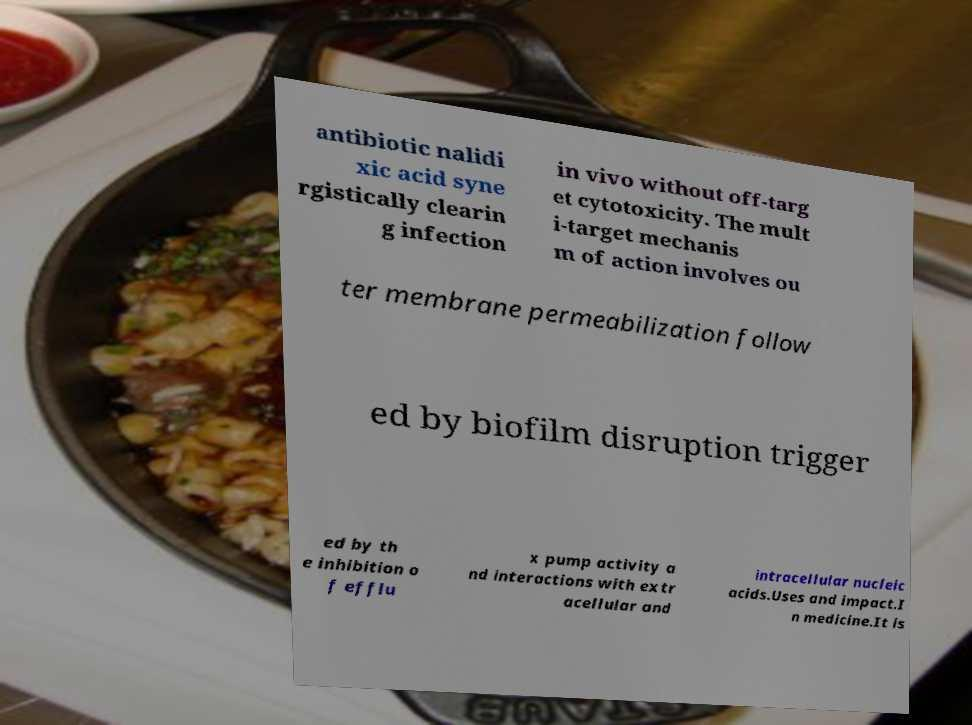Could you extract and type out the text from this image? antibiotic nalidi xic acid syne rgistically clearin g infection in vivo without off-targ et cytotoxicity. The mult i-target mechanis m of action involves ou ter membrane permeabilization follow ed by biofilm disruption trigger ed by th e inhibition o f efflu x pump activity a nd interactions with extr acellular and intracellular nucleic acids.Uses and impact.I n medicine.It is 